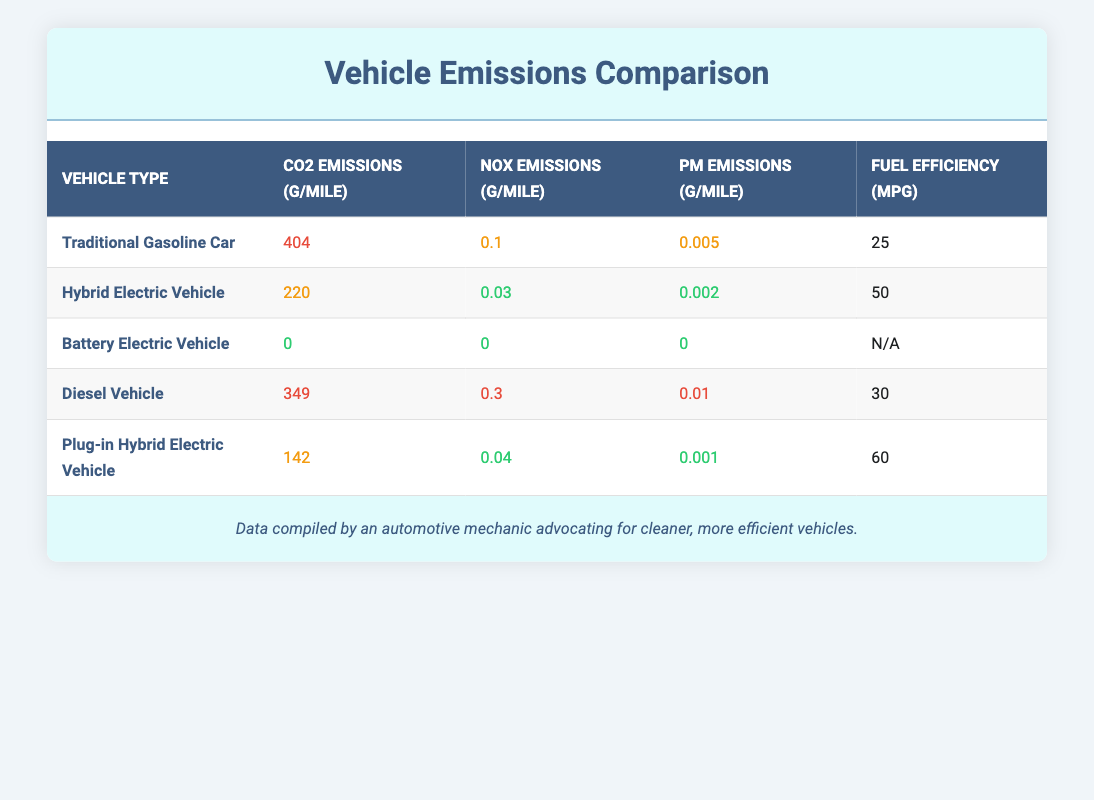What are the CO2 emissions per mile for a Battery Electric Vehicle? The table lists the CO2 emissions per mile for a Battery Electric Vehicle as 0 g/mile, indicating that it produces no CO2 emissions during operation.
Answer: 0 Which vehicle type has the highest NOx emissions per mile? The table shows that the Diesel Vehicle has the highest NOx emissions at 0.3 g/mile compared to the others.
Answer: Diesel Vehicle What is the average CO2 emissions per mile for all non-electric vehicles? The CO2 emissions for non-electric vehicles are 404 (Traditional Gasoline Car), 349 (Diesel Vehicle), 220 (Hybrid Electric Vehicle), and 142 (Plug-in Hybrid Electric Vehicle). Summing these gives 404 + 349 + 220 + 142 = 1115. There are 4 vehicles, so the average CO2 emissions is 1115 / 4 = 278.75 g/mile.
Answer: 278.75 Does the Plug-in Hybrid Electric Vehicle produce more PM emissions than the Hybrid Electric Vehicle? The Plug-in Hybrid Electric Vehicle has PM emissions of 0.001 g/mile, while the Hybrid Electric Vehicle has PM emissions of 0.002 g/mile. Since 0.001 is less than 0.002, the statement is false.
Answer: No What is the fuel efficiency of the vehicle with the lowest PM emissions? The Battery Electric Vehicle has 0 PM emissions (the lowest), and since its fuel efficiency is marked as N/A, we cannot quantify it. Therefore, the answer is that it does not have a fuel efficiency value listed.
Answer: N/A 